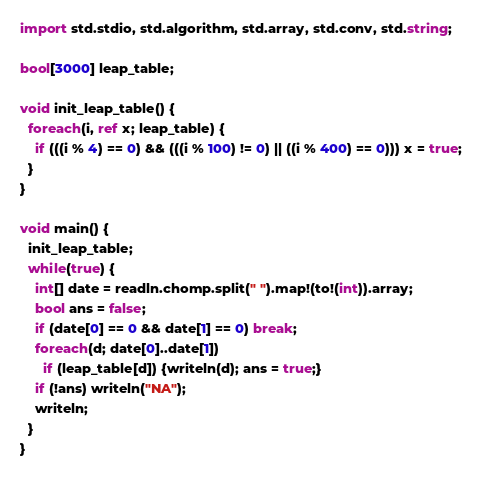<code> <loc_0><loc_0><loc_500><loc_500><_D_>
import std.stdio, std.algorithm, std.array, std.conv, std.string;

bool[3000] leap_table;

void init_leap_table() {
  foreach(i, ref x; leap_table) {
    if (((i % 4) == 0) && (((i % 100) != 0) || ((i % 400) == 0))) x = true;
  }
}

void main() {
  init_leap_table;
  while(true) {
    int[] date = readln.chomp.split(" ").map!(to!(int)).array;
    bool ans = false;
    if (date[0] == 0 && date[1] == 0) break;
    foreach(d; date[0]..date[1])
      if (leap_table[d]) {writeln(d); ans = true;}
    if (!ans) writeln("NA");
    writeln;
  }
}</code> 